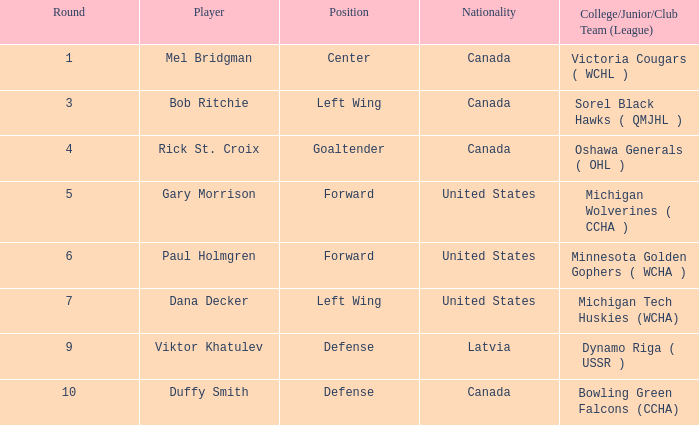Who is the forward player from the united states that has been involved in more than 5 rounds? Paul Holmgren. 